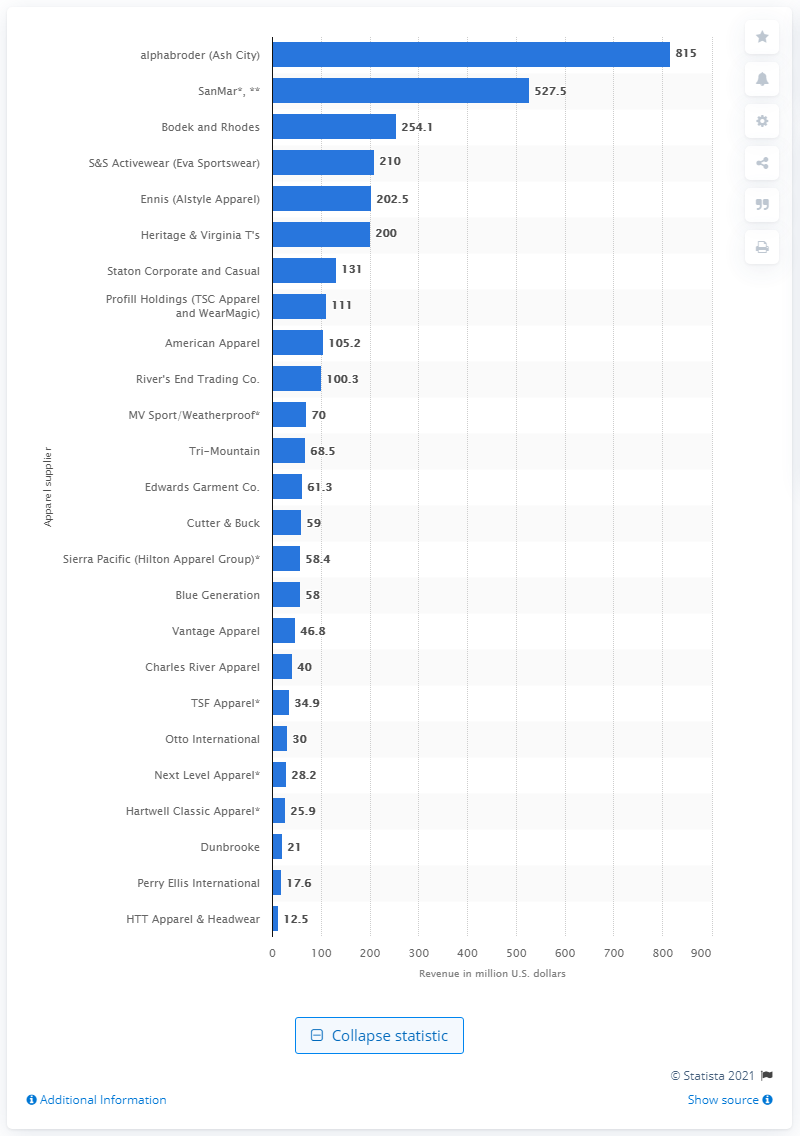Outline some significant characteristics in this image. In 2014, Alphabroder's revenue was approximately 815. 